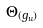Convert formula to latex. <formula><loc_0><loc_0><loc_500><loc_500>\Theta _ { ( g _ { u } ) }</formula> 